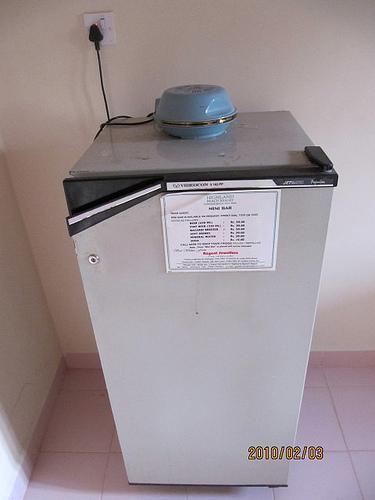How many refrigerators can be seen?
Give a very brief answer. 1. How many cats are facing away?
Give a very brief answer. 0. 